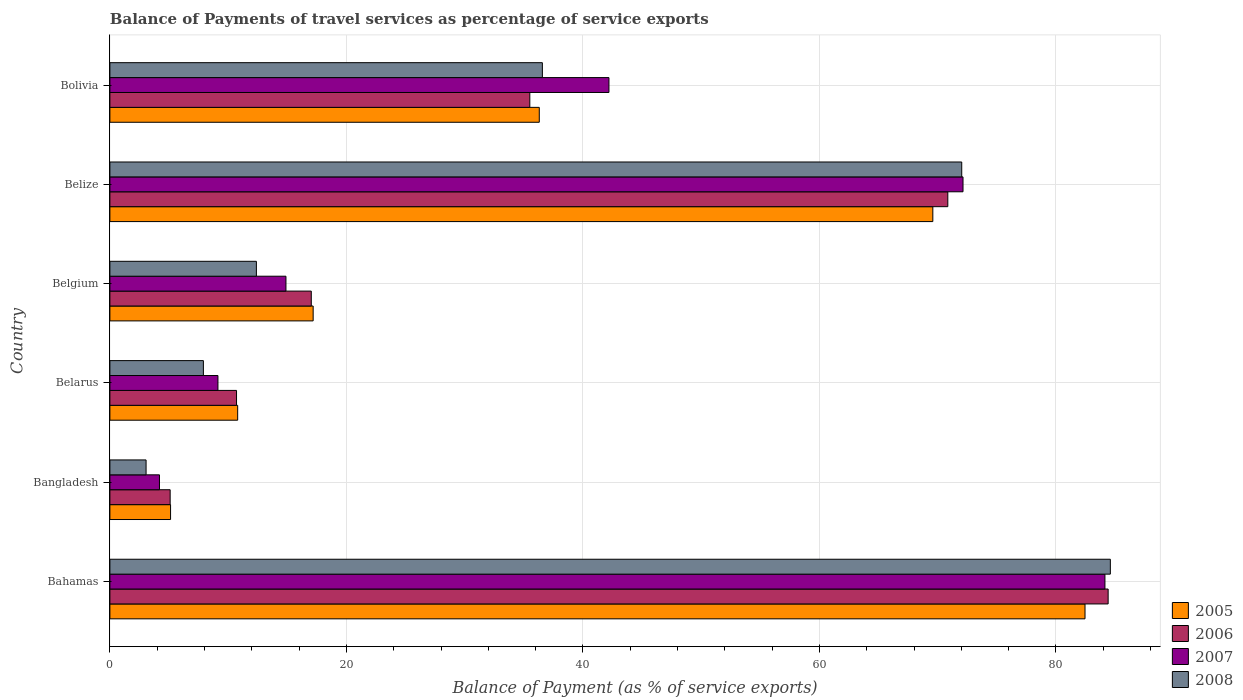How many different coloured bars are there?
Your response must be concise. 4. How many groups of bars are there?
Provide a short and direct response. 6. Are the number of bars on each tick of the Y-axis equal?
Keep it short and to the point. Yes. How many bars are there on the 4th tick from the top?
Your response must be concise. 4. What is the label of the 3rd group of bars from the top?
Keep it short and to the point. Belgium. What is the balance of payments of travel services in 2005 in Belarus?
Give a very brief answer. 10.81. Across all countries, what is the maximum balance of payments of travel services in 2006?
Your answer should be very brief. 84.42. Across all countries, what is the minimum balance of payments of travel services in 2005?
Your answer should be very brief. 5.13. In which country was the balance of payments of travel services in 2008 maximum?
Your response must be concise. Bahamas. In which country was the balance of payments of travel services in 2008 minimum?
Your response must be concise. Bangladesh. What is the total balance of payments of travel services in 2005 in the graph?
Keep it short and to the point. 221.49. What is the difference between the balance of payments of travel services in 2007 in Bangladesh and that in Bolivia?
Make the answer very short. -38.01. What is the difference between the balance of payments of travel services in 2006 in Bangladesh and the balance of payments of travel services in 2008 in Bahamas?
Provide a succinct answer. -79.51. What is the average balance of payments of travel services in 2008 per country?
Your response must be concise. 36.09. What is the difference between the balance of payments of travel services in 2007 and balance of payments of travel services in 2005 in Belarus?
Make the answer very short. -1.67. In how many countries, is the balance of payments of travel services in 2008 greater than 80 %?
Give a very brief answer. 1. What is the ratio of the balance of payments of travel services in 2005 in Bahamas to that in Belarus?
Your response must be concise. 7.63. Is the balance of payments of travel services in 2005 in Bangladesh less than that in Belgium?
Keep it short and to the point. Yes. What is the difference between the highest and the second highest balance of payments of travel services in 2006?
Offer a very short reply. 13.56. What is the difference between the highest and the lowest balance of payments of travel services in 2007?
Keep it short and to the point. 79.95. In how many countries, is the balance of payments of travel services in 2005 greater than the average balance of payments of travel services in 2005 taken over all countries?
Ensure brevity in your answer.  2. Is it the case that in every country, the sum of the balance of payments of travel services in 2005 and balance of payments of travel services in 2008 is greater than the balance of payments of travel services in 2006?
Your answer should be very brief. Yes. Are the values on the major ticks of X-axis written in scientific E-notation?
Ensure brevity in your answer.  No. Does the graph contain any zero values?
Your answer should be compact. No. Where does the legend appear in the graph?
Ensure brevity in your answer.  Bottom right. How many legend labels are there?
Offer a very short reply. 4. What is the title of the graph?
Ensure brevity in your answer.  Balance of Payments of travel services as percentage of service exports. Does "2011" appear as one of the legend labels in the graph?
Your response must be concise. No. What is the label or title of the X-axis?
Your response must be concise. Balance of Payment (as % of service exports). What is the Balance of Payment (as % of service exports) in 2005 in Bahamas?
Offer a very short reply. 82.46. What is the Balance of Payment (as % of service exports) of 2006 in Bahamas?
Offer a very short reply. 84.42. What is the Balance of Payment (as % of service exports) of 2007 in Bahamas?
Your answer should be very brief. 84.14. What is the Balance of Payment (as % of service exports) of 2008 in Bahamas?
Provide a short and direct response. 84.6. What is the Balance of Payment (as % of service exports) of 2005 in Bangladesh?
Your response must be concise. 5.13. What is the Balance of Payment (as % of service exports) of 2006 in Bangladesh?
Your response must be concise. 5.1. What is the Balance of Payment (as % of service exports) in 2007 in Bangladesh?
Provide a short and direct response. 4.19. What is the Balance of Payment (as % of service exports) of 2008 in Bangladesh?
Provide a short and direct response. 3.06. What is the Balance of Payment (as % of service exports) in 2005 in Belarus?
Keep it short and to the point. 10.81. What is the Balance of Payment (as % of service exports) in 2006 in Belarus?
Provide a short and direct response. 10.71. What is the Balance of Payment (as % of service exports) of 2007 in Belarus?
Offer a terse response. 9.14. What is the Balance of Payment (as % of service exports) in 2008 in Belarus?
Offer a terse response. 7.91. What is the Balance of Payment (as % of service exports) in 2005 in Belgium?
Provide a succinct answer. 17.19. What is the Balance of Payment (as % of service exports) in 2006 in Belgium?
Provide a short and direct response. 17.03. What is the Balance of Payment (as % of service exports) of 2007 in Belgium?
Make the answer very short. 14.89. What is the Balance of Payment (as % of service exports) of 2008 in Belgium?
Your answer should be very brief. 12.39. What is the Balance of Payment (as % of service exports) in 2005 in Belize?
Make the answer very short. 69.59. What is the Balance of Payment (as % of service exports) in 2006 in Belize?
Offer a very short reply. 70.86. What is the Balance of Payment (as % of service exports) in 2007 in Belize?
Your answer should be very brief. 72.14. What is the Balance of Payment (as % of service exports) in 2008 in Belize?
Provide a short and direct response. 72.03. What is the Balance of Payment (as % of service exports) of 2005 in Bolivia?
Provide a succinct answer. 36.31. What is the Balance of Payment (as % of service exports) of 2006 in Bolivia?
Provide a succinct answer. 35.51. What is the Balance of Payment (as % of service exports) in 2007 in Bolivia?
Your response must be concise. 42.2. What is the Balance of Payment (as % of service exports) in 2008 in Bolivia?
Make the answer very short. 36.57. Across all countries, what is the maximum Balance of Payment (as % of service exports) in 2005?
Your response must be concise. 82.46. Across all countries, what is the maximum Balance of Payment (as % of service exports) in 2006?
Make the answer very short. 84.42. Across all countries, what is the maximum Balance of Payment (as % of service exports) of 2007?
Give a very brief answer. 84.14. Across all countries, what is the maximum Balance of Payment (as % of service exports) of 2008?
Keep it short and to the point. 84.6. Across all countries, what is the minimum Balance of Payment (as % of service exports) in 2005?
Make the answer very short. 5.13. Across all countries, what is the minimum Balance of Payment (as % of service exports) of 2006?
Your response must be concise. 5.1. Across all countries, what is the minimum Balance of Payment (as % of service exports) of 2007?
Your response must be concise. 4.19. Across all countries, what is the minimum Balance of Payment (as % of service exports) in 2008?
Your answer should be very brief. 3.06. What is the total Balance of Payment (as % of service exports) of 2005 in the graph?
Keep it short and to the point. 221.49. What is the total Balance of Payment (as % of service exports) of 2006 in the graph?
Your answer should be very brief. 223.62. What is the total Balance of Payment (as % of service exports) of 2007 in the graph?
Give a very brief answer. 226.71. What is the total Balance of Payment (as % of service exports) of 2008 in the graph?
Give a very brief answer. 216.57. What is the difference between the Balance of Payment (as % of service exports) of 2005 in Bahamas and that in Bangladesh?
Provide a short and direct response. 77.33. What is the difference between the Balance of Payment (as % of service exports) in 2006 in Bahamas and that in Bangladesh?
Ensure brevity in your answer.  79.32. What is the difference between the Balance of Payment (as % of service exports) in 2007 in Bahamas and that in Bangladesh?
Keep it short and to the point. 79.95. What is the difference between the Balance of Payment (as % of service exports) in 2008 in Bahamas and that in Bangladesh?
Your answer should be very brief. 81.54. What is the difference between the Balance of Payment (as % of service exports) in 2005 in Bahamas and that in Belarus?
Offer a terse response. 71.66. What is the difference between the Balance of Payment (as % of service exports) of 2006 in Bahamas and that in Belarus?
Your response must be concise. 73.71. What is the difference between the Balance of Payment (as % of service exports) of 2007 in Bahamas and that in Belarus?
Give a very brief answer. 75.01. What is the difference between the Balance of Payment (as % of service exports) in 2008 in Bahamas and that in Belarus?
Offer a very short reply. 76.7. What is the difference between the Balance of Payment (as % of service exports) in 2005 in Bahamas and that in Belgium?
Offer a very short reply. 65.27. What is the difference between the Balance of Payment (as % of service exports) in 2006 in Bahamas and that in Belgium?
Ensure brevity in your answer.  67.38. What is the difference between the Balance of Payment (as % of service exports) of 2007 in Bahamas and that in Belgium?
Keep it short and to the point. 69.26. What is the difference between the Balance of Payment (as % of service exports) of 2008 in Bahamas and that in Belgium?
Offer a terse response. 72.21. What is the difference between the Balance of Payment (as % of service exports) in 2005 in Bahamas and that in Belize?
Offer a terse response. 12.87. What is the difference between the Balance of Payment (as % of service exports) of 2006 in Bahamas and that in Belize?
Your response must be concise. 13.56. What is the difference between the Balance of Payment (as % of service exports) in 2007 in Bahamas and that in Belize?
Make the answer very short. 12. What is the difference between the Balance of Payment (as % of service exports) in 2008 in Bahamas and that in Belize?
Ensure brevity in your answer.  12.57. What is the difference between the Balance of Payment (as % of service exports) in 2005 in Bahamas and that in Bolivia?
Offer a very short reply. 46.15. What is the difference between the Balance of Payment (as % of service exports) of 2006 in Bahamas and that in Bolivia?
Give a very brief answer. 48.91. What is the difference between the Balance of Payment (as % of service exports) in 2007 in Bahamas and that in Bolivia?
Keep it short and to the point. 41.94. What is the difference between the Balance of Payment (as % of service exports) in 2008 in Bahamas and that in Bolivia?
Make the answer very short. 48.03. What is the difference between the Balance of Payment (as % of service exports) of 2005 in Bangladesh and that in Belarus?
Give a very brief answer. -5.67. What is the difference between the Balance of Payment (as % of service exports) of 2006 in Bangladesh and that in Belarus?
Provide a short and direct response. -5.61. What is the difference between the Balance of Payment (as % of service exports) in 2007 in Bangladesh and that in Belarus?
Give a very brief answer. -4.94. What is the difference between the Balance of Payment (as % of service exports) of 2008 in Bangladesh and that in Belarus?
Your answer should be very brief. -4.85. What is the difference between the Balance of Payment (as % of service exports) in 2005 in Bangladesh and that in Belgium?
Give a very brief answer. -12.06. What is the difference between the Balance of Payment (as % of service exports) in 2006 in Bangladesh and that in Belgium?
Keep it short and to the point. -11.94. What is the difference between the Balance of Payment (as % of service exports) in 2007 in Bangladesh and that in Belgium?
Give a very brief answer. -10.69. What is the difference between the Balance of Payment (as % of service exports) of 2008 in Bangladesh and that in Belgium?
Your answer should be compact. -9.33. What is the difference between the Balance of Payment (as % of service exports) of 2005 in Bangladesh and that in Belize?
Your answer should be very brief. -64.46. What is the difference between the Balance of Payment (as % of service exports) of 2006 in Bangladesh and that in Belize?
Your response must be concise. -65.76. What is the difference between the Balance of Payment (as % of service exports) in 2007 in Bangladesh and that in Belize?
Keep it short and to the point. -67.95. What is the difference between the Balance of Payment (as % of service exports) of 2008 in Bangladesh and that in Belize?
Offer a very short reply. -68.97. What is the difference between the Balance of Payment (as % of service exports) in 2005 in Bangladesh and that in Bolivia?
Provide a succinct answer. -31.18. What is the difference between the Balance of Payment (as % of service exports) in 2006 in Bangladesh and that in Bolivia?
Give a very brief answer. -30.41. What is the difference between the Balance of Payment (as % of service exports) of 2007 in Bangladesh and that in Bolivia?
Your answer should be very brief. -38.01. What is the difference between the Balance of Payment (as % of service exports) in 2008 in Bangladesh and that in Bolivia?
Keep it short and to the point. -33.51. What is the difference between the Balance of Payment (as % of service exports) in 2005 in Belarus and that in Belgium?
Your answer should be very brief. -6.38. What is the difference between the Balance of Payment (as % of service exports) of 2006 in Belarus and that in Belgium?
Make the answer very short. -6.32. What is the difference between the Balance of Payment (as % of service exports) of 2007 in Belarus and that in Belgium?
Ensure brevity in your answer.  -5.75. What is the difference between the Balance of Payment (as % of service exports) of 2008 in Belarus and that in Belgium?
Your answer should be compact. -4.48. What is the difference between the Balance of Payment (as % of service exports) in 2005 in Belarus and that in Belize?
Your answer should be very brief. -58.78. What is the difference between the Balance of Payment (as % of service exports) in 2006 in Belarus and that in Belize?
Offer a terse response. -60.15. What is the difference between the Balance of Payment (as % of service exports) of 2007 in Belarus and that in Belize?
Provide a short and direct response. -63.01. What is the difference between the Balance of Payment (as % of service exports) in 2008 in Belarus and that in Belize?
Your response must be concise. -64.13. What is the difference between the Balance of Payment (as % of service exports) in 2005 in Belarus and that in Bolivia?
Keep it short and to the point. -25.5. What is the difference between the Balance of Payment (as % of service exports) of 2006 in Belarus and that in Bolivia?
Offer a very short reply. -24.8. What is the difference between the Balance of Payment (as % of service exports) of 2007 in Belarus and that in Bolivia?
Your response must be concise. -33.07. What is the difference between the Balance of Payment (as % of service exports) in 2008 in Belarus and that in Bolivia?
Give a very brief answer. -28.67. What is the difference between the Balance of Payment (as % of service exports) in 2005 in Belgium and that in Belize?
Make the answer very short. -52.4. What is the difference between the Balance of Payment (as % of service exports) in 2006 in Belgium and that in Belize?
Offer a terse response. -53.83. What is the difference between the Balance of Payment (as % of service exports) in 2007 in Belgium and that in Belize?
Provide a short and direct response. -57.26. What is the difference between the Balance of Payment (as % of service exports) of 2008 in Belgium and that in Belize?
Your answer should be compact. -59.65. What is the difference between the Balance of Payment (as % of service exports) in 2005 in Belgium and that in Bolivia?
Your answer should be compact. -19.12. What is the difference between the Balance of Payment (as % of service exports) of 2006 in Belgium and that in Bolivia?
Your answer should be compact. -18.48. What is the difference between the Balance of Payment (as % of service exports) in 2007 in Belgium and that in Bolivia?
Keep it short and to the point. -27.31. What is the difference between the Balance of Payment (as % of service exports) in 2008 in Belgium and that in Bolivia?
Provide a succinct answer. -24.18. What is the difference between the Balance of Payment (as % of service exports) of 2005 in Belize and that in Bolivia?
Make the answer very short. 33.28. What is the difference between the Balance of Payment (as % of service exports) of 2006 in Belize and that in Bolivia?
Give a very brief answer. 35.35. What is the difference between the Balance of Payment (as % of service exports) of 2007 in Belize and that in Bolivia?
Offer a very short reply. 29.94. What is the difference between the Balance of Payment (as % of service exports) in 2008 in Belize and that in Bolivia?
Keep it short and to the point. 35.46. What is the difference between the Balance of Payment (as % of service exports) of 2005 in Bahamas and the Balance of Payment (as % of service exports) of 2006 in Bangladesh?
Give a very brief answer. 77.36. What is the difference between the Balance of Payment (as % of service exports) of 2005 in Bahamas and the Balance of Payment (as % of service exports) of 2007 in Bangladesh?
Your answer should be very brief. 78.27. What is the difference between the Balance of Payment (as % of service exports) of 2005 in Bahamas and the Balance of Payment (as % of service exports) of 2008 in Bangladesh?
Keep it short and to the point. 79.4. What is the difference between the Balance of Payment (as % of service exports) in 2006 in Bahamas and the Balance of Payment (as % of service exports) in 2007 in Bangladesh?
Provide a succinct answer. 80.22. What is the difference between the Balance of Payment (as % of service exports) of 2006 in Bahamas and the Balance of Payment (as % of service exports) of 2008 in Bangladesh?
Offer a very short reply. 81.36. What is the difference between the Balance of Payment (as % of service exports) in 2007 in Bahamas and the Balance of Payment (as % of service exports) in 2008 in Bangladesh?
Make the answer very short. 81.08. What is the difference between the Balance of Payment (as % of service exports) of 2005 in Bahamas and the Balance of Payment (as % of service exports) of 2006 in Belarus?
Your answer should be very brief. 71.75. What is the difference between the Balance of Payment (as % of service exports) in 2005 in Bahamas and the Balance of Payment (as % of service exports) in 2007 in Belarus?
Give a very brief answer. 73.32. What is the difference between the Balance of Payment (as % of service exports) in 2005 in Bahamas and the Balance of Payment (as % of service exports) in 2008 in Belarus?
Your answer should be very brief. 74.55. What is the difference between the Balance of Payment (as % of service exports) in 2006 in Bahamas and the Balance of Payment (as % of service exports) in 2007 in Belarus?
Your response must be concise. 75.28. What is the difference between the Balance of Payment (as % of service exports) in 2006 in Bahamas and the Balance of Payment (as % of service exports) in 2008 in Belarus?
Offer a terse response. 76.51. What is the difference between the Balance of Payment (as % of service exports) of 2007 in Bahamas and the Balance of Payment (as % of service exports) of 2008 in Belarus?
Your response must be concise. 76.24. What is the difference between the Balance of Payment (as % of service exports) of 2005 in Bahamas and the Balance of Payment (as % of service exports) of 2006 in Belgium?
Make the answer very short. 65.43. What is the difference between the Balance of Payment (as % of service exports) in 2005 in Bahamas and the Balance of Payment (as % of service exports) in 2007 in Belgium?
Give a very brief answer. 67.57. What is the difference between the Balance of Payment (as % of service exports) of 2005 in Bahamas and the Balance of Payment (as % of service exports) of 2008 in Belgium?
Your answer should be very brief. 70.07. What is the difference between the Balance of Payment (as % of service exports) of 2006 in Bahamas and the Balance of Payment (as % of service exports) of 2007 in Belgium?
Provide a short and direct response. 69.53. What is the difference between the Balance of Payment (as % of service exports) of 2006 in Bahamas and the Balance of Payment (as % of service exports) of 2008 in Belgium?
Make the answer very short. 72.03. What is the difference between the Balance of Payment (as % of service exports) in 2007 in Bahamas and the Balance of Payment (as % of service exports) in 2008 in Belgium?
Keep it short and to the point. 71.76. What is the difference between the Balance of Payment (as % of service exports) in 2005 in Bahamas and the Balance of Payment (as % of service exports) in 2006 in Belize?
Keep it short and to the point. 11.6. What is the difference between the Balance of Payment (as % of service exports) of 2005 in Bahamas and the Balance of Payment (as % of service exports) of 2007 in Belize?
Make the answer very short. 10.32. What is the difference between the Balance of Payment (as % of service exports) in 2005 in Bahamas and the Balance of Payment (as % of service exports) in 2008 in Belize?
Offer a very short reply. 10.43. What is the difference between the Balance of Payment (as % of service exports) of 2006 in Bahamas and the Balance of Payment (as % of service exports) of 2007 in Belize?
Offer a terse response. 12.27. What is the difference between the Balance of Payment (as % of service exports) of 2006 in Bahamas and the Balance of Payment (as % of service exports) of 2008 in Belize?
Give a very brief answer. 12.38. What is the difference between the Balance of Payment (as % of service exports) in 2007 in Bahamas and the Balance of Payment (as % of service exports) in 2008 in Belize?
Offer a terse response. 12.11. What is the difference between the Balance of Payment (as % of service exports) in 2005 in Bahamas and the Balance of Payment (as % of service exports) in 2006 in Bolivia?
Ensure brevity in your answer.  46.95. What is the difference between the Balance of Payment (as % of service exports) in 2005 in Bahamas and the Balance of Payment (as % of service exports) in 2007 in Bolivia?
Ensure brevity in your answer.  40.26. What is the difference between the Balance of Payment (as % of service exports) of 2005 in Bahamas and the Balance of Payment (as % of service exports) of 2008 in Bolivia?
Offer a very short reply. 45.89. What is the difference between the Balance of Payment (as % of service exports) in 2006 in Bahamas and the Balance of Payment (as % of service exports) in 2007 in Bolivia?
Offer a terse response. 42.21. What is the difference between the Balance of Payment (as % of service exports) of 2006 in Bahamas and the Balance of Payment (as % of service exports) of 2008 in Bolivia?
Provide a succinct answer. 47.84. What is the difference between the Balance of Payment (as % of service exports) of 2007 in Bahamas and the Balance of Payment (as % of service exports) of 2008 in Bolivia?
Ensure brevity in your answer.  47.57. What is the difference between the Balance of Payment (as % of service exports) of 2005 in Bangladesh and the Balance of Payment (as % of service exports) of 2006 in Belarus?
Keep it short and to the point. -5.58. What is the difference between the Balance of Payment (as % of service exports) in 2005 in Bangladesh and the Balance of Payment (as % of service exports) in 2007 in Belarus?
Provide a succinct answer. -4.01. What is the difference between the Balance of Payment (as % of service exports) of 2005 in Bangladesh and the Balance of Payment (as % of service exports) of 2008 in Belarus?
Your answer should be compact. -2.78. What is the difference between the Balance of Payment (as % of service exports) of 2006 in Bangladesh and the Balance of Payment (as % of service exports) of 2007 in Belarus?
Make the answer very short. -4.04. What is the difference between the Balance of Payment (as % of service exports) in 2006 in Bangladesh and the Balance of Payment (as % of service exports) in 2008 in Belarus?
Give a very brief answer. -2.81. What is the difference between the Balance of Payment (as % of service exports) of 2007 in Bangladesh and the Balance of Payment (as % of service exports) of 2008 in Belarus?
Your answer should be very brief. -3.71. What is the difference between the Balance of Payment (as % of service exports) of 2005 in Bangladesh and the Balance of Payment (as % of service exports) of 2006 in Belgium?
Your response must be concise. -11.9. What is the difference between the Balance of Payment (as % of service exports) of 2005 in Bangladesh and the Balance of Payment (as % of service exports) of 2007 in Belgium?
Provide a short and direct response. -9.76. What is the difference between the Balance of Payment (as % of service exports) of 2005 in Bangladesh and the Balance of Payment (as % of service exports) of 2008 in Belgium?
Your answer should be compact. -7.26. What is the difference between the Balance of Payment (as % of service exports) of 2006 in Bangladesh and the Balance of Payment (as % of service exports) of 2007 in Belgium?
Provide a short and direct response. -9.79. What is the difference between the Balance of Payment (as % of service exports) of 2006 in Bangladesh and the Balance of Payment (as % of service exports) of 2008 in Belgium?
Offer a very short reply. -7.29. What is the difference between the Balance of Payment (as % of service exports) in 2007 in Bangladesh and the Balance of Payment (as % of service exports) in 2008 in Belgium?
Give a very brief answer. -8.2. What is the difference between the Balance of Payment (as % of service exports) of 2005 in Bangladesh and the Balance of Payment (as % of service exports) of 2006 in Belize?
Give a very brief answer. -65.73. What is the difference between the Balance of Payment (as % of service exports) of 2005 in Bangladesh and the Balance of Payment (as % of service exports) of 2007 in Belize?
Your answer should be compact. -67.01. What is the difference between the Balance of Payment (as % of service exports) in 2005 in Bangladesh and the Balance of Payment (as % of service exports) in 2008 in Belize?
Your answer should be compact. -66.9. What is the difference between the Balance of Payment (as % of service exports) in 2006 in Bangladesh and the Balance of Payment (as % of service exports) in 2007 in Belize?
Make the answer very short. -67.05. What is the difference between the Balance of Payment (as % of service exports) in 2006 in Bangladesh and the Balance of Payment (as % of service exports) in 2008 in Belize?
Your response must be concise. -66.94. What is the difference between the Balance of Payment (as % of service exports) of 2007 in Bangladesh and the Balance of Payment (as % of service exports) of 2008 in Belize?
Offer a terse response. -67.84. What is the difference between the Balance of Payment (as % of service exports) in 2005 in Bangladesh and the Balance of Payment (as % of service exports) in 2006 in Bolivia?
Ensure brevity in your answer.  -30.38. What is the difference between the Balance of Payment (as % of service exports) of 2005 in Bangladesh and the Balance of Payment (as % of service exports) of 2007 in Bolivia?
Offer a terse response. -37.07. What is the difference between the Balance of Payment (as % of service exports) in 2005 in Bangladesh and the Balance of Payment (as % of service exports) in 2008 in Bolivia?
Give a very brief answer. -31.44. What is the difference between the Balance of Payment (as % of service exports) in 2006 in Bangladesh and the Balance of Payment (as % of service exports) in 2007 in Bolivia?
Offer a very short reply. -37.11. What is the difference between the Balance of Payment (as % of service exports) of 2006 in Bangladesh and the Balance of Payment (as % of service exports) of 2008 in Bolivia?
Offer a very short reply. -31.48. What is the difference between the Balance of Payment (as % of service exports) in 2007 in Bangladesh and the Balance of Payment (as % of service exports) in 2008 in Bolivia?
Give a very brief answer. -32.38. What is the difference between the Balance of Payment (as % of service exports) in 2005 in Belarus and the Balance of Payment (as % of service exports) in 2006 in Belgium?
Your answer should be compact. -6.23. What is the difference between the Balance of Payment (as % of service exports) in 2005 in Belarus and the Balance of Payment (as % of service exports) in 2007 in Belgium?
Ensure brevity in your answer.  -4.08. What is the difference between the Balance of Payment (as % of service exports) in 2005 in Belarus and the Balance of Payment (as % of service exports) in 2008 in Belgium?
Your answer should be compact. -1.58. What is the difference between the Balance of Payment (as % of service exports) in 2006 in Belarus and the Balance of Payment (as % of service exports) in 2007 in Belgium?
Ensure brevity in your answer.  -4.18. What is the difference between the Balance of Payment (as % of service exports) of 2006 in Belarus and the Balance of Payment (as % of service exports) of 2008 in Belgium?
Keep it short and to the point. -1.68. What is the difference between the Balance of Payment (as % of service exports) of 2007 in Belarus and the Balance of Payment (as % of service exports) of 2008 in Belgium?
Ensure brevity in your answer.  -3.25. What is the difference between the Balance of Payment (as % of service exports) in 2005 in Belarus and the Balance of Payment (as % of service exports) in 2006 in Belize?
Your answer should be very brief. -60.05. What is the difference between the Balance of Payment (as % of service exports) of 2005 in Belarus and the Balance of Payment (as % of service exports) of 2007 in Belize?
Your answer should be compact. -61.34. What is the difference between the Balance of Payment (as % of service exports) of 2005 in Belarus and the Balance of Payment (as % of service exports) of 2008 in Belize?
Offer a terse response. -61.23. What is the difference between the Balance of Payment (as % of service exports) of 2006 in Belarus and the Balance of Payment (as % of service exports) of 2007 in Belize?
Keep it short and to the point. -61.43. What is the difference between the Balance of Payment (as % of service exports) of 2006 in Belarus and the Balance of Payment (as % of service exports) of 2008 in Belize?
Your response must be concise. -61.33. What is the difference between the Balance of Payment (as % of service exports) in 2007 in Belarus and the Balance of Payment (as % of service exports) in 2008 in Belize?
Your answer should be compact. -62.9. What is the difference between the Balance of Payment (as % of service exports) of 2005 in Belarus and the Balance of Payment (as % of service exports) of 2006 in Bolivia?
Provide a succinct answer. -24.7. What is the difference between the Balance of Payment (as % of service exports) of 2005 in Belarus and the Balance of Payment (as % of service exports) of 2007 in Bolivia?
Your answer should be very brief. -31.4. What is the difference between the Balance of Payment (as % of service exports) of 2005 in Belarus and the Balance of Payment (as % of service exports) of 2008 in Bolivia?
Your answer should be very brief. -25.77. What is the difference between the Balance of Payment (as % of service exports) of 2006 in Belarus and the Balance of Payment (as % of service exports) of 2007 in Bolivia?
Ensure brevity in your answer.  -31.49. What is the difference between the Balance of Payment (as % of service exports) in 2006 in Belarus and the Balance of Payment (as % of service exports) in 2008 in Bolivia?
Offer a terse response. -25.86. What is the difference between the Balance of Payment (as % of service exports) of 2007 in Belarus and the Balance of Payment (as % of service exports) of 2008 in Bolivia?
Make the answer very short. -27.44. What is the difference between the Balance of Payment (as % of service exports) in 2005 in Belgium and the Balance of Payment (as % of service exports) in 2006 in Belize?
Provide a short and direct response. -53.67. What is the difference between the Balance of Payment (as % of service exports) of 2005 in Belgium and the Balance of Payment (as % of service exports) of 2007 in Belize?
Offer a very short reply. -54.95. What is the difference between the Balance of Payment (as % of service exports) in 2005 in Belgium and the Balance of Payment (as % of service exports) in 2008 in Belize?
Your response must be concise. -54.85. What is the difference between the Balance of Payment (as % of service exports) in 2006 in Belgium and the Balance of Payment (as % of service exports) in 2007 in Belize?
Keep it short and to the point. -55.11. What is the difference between the Balance of Payment (as % of service exports) in 2006 in Belgium and the Balance of Payment (as % of service exports) in 2008 in Belize?
Your response must be concise. -55. What is the difference between the Balance of Payment (as % of service exports) of 2007 in Belgium and the Balance of Payment (as % of service exports) of 2008 in Belize?
Your answer should be compact. -57.15. What is the difference between the Balance of Payment (as % of service exports) in 2005 in Belgium and the Balance of Payment (as % of service exports) in 2006 in Bolivia?
Offer a very short reply. -18.32. What is the difference between the Balance of Payment (as % of service exports) of 2005 in Belgium and the Balance of Payment (as % of service exports) of 2007 in Bolivia?
Your answer should be very brief. -25.01. What is the difference between the Balance of Payment (as % of service exports) in 2005 in Belgium and the Balance of Payment (as % of service exports) in 2008 in Bolivia?
Your answer should be very brief. -19.38. What is the difference between the Balance of Payment (as % of service exports) of 2006 in Belgium and the Balance of Payment (as % of service exports) of 2007 in Bolivia?
Give a very brief answer. -25.17. What is the difference between the Balance of Payment (as % of service exports) in 2006 in Belgium and the Balance of Payment (as % of service exports) in 2008 in Bolivia?
Your answer should be compact. -19.54. What is the difference between the Balance of Payment (as % of service exports) in 2007 in Belgium and the Balance of Payment (as % of service exports) in 2008 in Bolivia?
Keep it short and to the point. -21.68. What is the difference between the Balance of Payment (as % of service exports) of 2005 in Belize and the Balance of Payment (as % of service exports) of 2006 in Bolivia?
Make the answer very short. 34.08. What is the difference between the Balance of Payment (as % of service exports) in 2005 in Belize and the Balance of Payment (as % of service exports) in 2007 in Bolivia?
Offer a terse response. 27.39. What is the difference between the Balance of Payment (as % of service exports) in 2005 in Belize and the Balance of Payment (as % of service exports) in 2008 in Bolivia?
Keep it short and to the point. 33.02. What is the difference between the Balance of Payment (as % of service exports) in 2006 in Belize and the Balance of Payment (as % of service exports) in 2007 in Bolivia?
Make the answer very short. 28.66. What is the difference between the Balance of Payment (as % of service exports) of 2006 in Belize and the Balance of Payment (as % of service exports) of 2008 in Bolivia?
Provide a succinct answer. 34.29. What is the difference between the Balance of Payment (as % of service exports) of 2007 in Belize and the Balance of Payment (as % of service exports) of 2008 in Bolivia?
Provide a succinct answer. 35.57. What is the average Balance of Payment (as % of service exports) in 2005 per country?
Ensure brevity in your answer.  36.91. What is the average Balance of Payment (as % of service exports) of 2006 per country?
Your answer should be compact. 37.27. What is the average Balance of Payment (as % of service exports) in 2007 per country?
Offer a terse response. 37.78. What is the average Balance of Payment (as % of service exports) in 2008 per country?
Offer a terse response. 36.09. What is the difference between the Balance of Payment (as % of service exports) of 2005 and Balance of Payment (as % of service exports) of 2006 in Bahamas?
Your answer should be compact. -1.95. What is the difference between the Balance of Payment (as % of service exports) in 2005 and Balance of Payment (as % of service exports) in 2007 in Bahamas?
Give a very brief answer. -1.68. What is the difference between the Balance of Payment (as % of service exports) of 2005 and Balance of Payment (as % of service exports) of 2008 in Bahamas?
Your answer should be very brief. -2.14. What is the difference between the Balance of Payment (as % of service exports) in 2006 and Balance of Payment (as % of service exports) in 2007 in Bahamas?
Keep it short and to the point. 0.27. What is the difference between the Balance of Payment (as % of service exports) in 2006 and Balance of Payment (as % of service exports) in 2008 in Bahamas?
Provide a short and direct response. -0.19. What is the difference between the Balance of Payment (as % of service exports) in 2007 and Balance of Payment (as % of service exports) in 2008 in Bahamas?
Ensure brevity in your answer.  -0.46. What is the difference between the Balance of Payment (as % of service exports) in 2005 and Balance of Payment (as % of service exports) in 2006 in Bangladesh?
Make the answer very short. 0.04. What is the difference between the Balance of Payment (as % of service exports) of 2005 and Balance of Payment (as % of service exports) of 2007 in Bangladesh?
Ensure brevity in your answer.  0.94. What is the difference between the Balance of Payment (as % of service exports) in 2005 and Balance of Payment (as % of service exports) in 2008 in Bangladesh?
Your answer should be very brief. 2.07. What is the difference between the Balance of Payment (as % of service exports) of 2006 and Balance of Payment (as % of service exports) of 2007 in Bangladesh?
Keep it short and to the point. 0.9. What is the difference between the Balance of Payment (as % of service exports) of 2006 and Balance of Payment (as % of service exports) of 2008 in Bangladesh?
Make the answer very short. 2.04. What is the difference between the Balance of Payment (as % of service exports) in 2007 and Balance of Payment (as % of service exports) in 2008 in Bangladesh?
Keep it short and to the point. 1.13. What is the difference between the Balance of Payment (as % of service exports) in 2005 and Balance of Payment (as % of service exports) in 2006 in Belarus?
Offer a very short reply. 0.1. What is the difference between the Balance of Payment (as % of service exports) in 2005 and Balance of Payment (as % of service exports) in 2007 in Belarus?
Offer a terse response. 1.67. What is the difference between the Balance of Payment (as % of service exports) of 2005 and Balance of Payment (as % of service exports) of 2008 in Belarus?
Your answer should be compact. 2.9. What is the difference between the Balance of Payment (as % of service exports) of 2006 and Balance of Payment (as % of service exports) of 2007 in Belarus?
Offer a very short reply. 1.57. What is the difference between the Balance of Payment (as % of service exports) of 2006 and Balance of Payment (as % of service exports) of 2008 in Belarus?
Your answer should be compact. 2.8. What is the difference between the Balance of Payment (as % of service exports) in 2007 and Balance of Payment (as % of service exports) in 2008 in Belarus?
Your answer should be very brief. 1.23. What is the difference between the Balance of Payment (as % of service exports) of 2005 and Balance of Payment (as % of service exports) of 2006 in Belgium?
Ensure brevity in your answer.  0.16. What is the difference between the Balance of Payment (as % of service exports) of 2005 and Balance of Payment (as % of service exports) of 2007 in Belgium?
Your answer should be very brief. 2.3. What is the difference between the Balance of Payment (as % of service exports) of 2005 and Balance of Payment (as % of service exports) of 2008 in Belgium?
Ensure brevity in your answer.  4.8. What is the difference between the Balance of Payment (as % of service exports) in 2006 and Balance of Payment (as % of service exports) in 2007 in Belgium?
Keep it short and to the point. 2.14. What is the difference between the Balance of Payment (as % of service exports) in 2006 and Balance of Payment (as % of service exports) in 2008 in Belgium?
Your answer should be compact. 4.64. What is the difference between the Balance of Payment (as % of service exports) of 2007 and Balance of Payment (as % of service exports) of 2008 in Belgium?
Provide a succinct answer. 2.5. What is the difference between the Balance of Payment (as % of service exports) in 2005 and Balance of Payment (as % of service exports) in 2006 in Belize?
Your response must be concise. -1.27. What is the difference between the Balance of Payment (as % of service exports) of 2005 and Balance of Payment (as % of service exports) of 2007 in Belize?
Provide a short and direct response. -2.55. What is the difference between the Balance of Payment (as % of service exports) of 2005 and Balance of Payment (as % of service exports) of 2008 in Belize?
Your answer should be very brief. -2.44. What is the difference between the Balance of Payment (as % of service exports) of 2006 and Balance of Payment (as % of service exports) of 2007 in Belize?
Your answer should be very brief. -1.28. What is the difference between the Balance of Payment (as % of service exports) of 2006 and Balance of Payment (as % of service exports) of 2008 in Belize?
Offer a terse response. -1.18. What is the difference between the Balance of Payment (as % of service exports) of 2007 and Balance of Payment (as % of service exports) of 2008 in Belize?
Make the answer very short. 0.11. What is the difference between the Balance of Payment (as % of service exports) in 2005 and Balance of Payment (as % of service exports) in 2006 in Bolivia?
Your response must be concise. 0.8. What is the difference between the Balance of Payment (as % of service exports) in 2005 and Balance of Payment (as % of service exports) in 2007 in Bolivia?
Your answer should be very brief. -5.89. What is the difference between the Balance of Payment (as % of service exports) of 2005 and Balance of Payment (as % of service exports) of 2008 in Bolivia?
Provide a succinct answer. -0.26. What is the difference between the Balance of Payment (as % of service exports) in 2006 and Balance of Payment (as % of service exports) in 2007 in Bolivia?
Keep it short and to the point. -6.69. What is the difference between the Balance of Payment (as % of service exports) in 2006 and Balance of Payment (as % of service exports) in 2008 in Bolivia?
Your response must be concise. -1.06. What is the difference between the Balance of Payment (as % of service exports) of 2007 and Balance of Payment (as % of service exports) of 2008 in Bolivia?
Your answer should be compact. 5.63. What is the ratio of the Balance of Payment (as % of service exports) of 2005 in Bahamas to that in Bangladesh?
Offer a terse response. 16.07. What is the ratio of the Balance of Payment (as % of service exports) of 2006 in Bahamas to that in Bangladesh?
Keep it short and to the point. 16.57. What is the ratio of the Balance of Payment (as % of service exports) in 2007 in Bahamas to that in Bangladesh?
Ensure brevity in your answer.  20.07. What is the ratio of the Balance of Payment (as % of service exports) of 2008 in Bahamas to that in Bangladesh?
Provide a succinct answer. 27.64. What is the ratio of the Balance of Payment (as % of service exports) in 2005 in Bahamas to that in Belarus?
Ensure brevity in your answer.  7.63. What is the ratio of the Balance of Payment (as % of service exports) in 2006 in Bahamas to that in Belarus?
Your answer should be compact. 7.88. What is the ratio of the Balance of Payment (as % of service exports) of 2007 in Bahamas to that in Belarus?
Your answer should be compact. 9.21. What is the ratio of the Balance of Payment (as % of service exports) of 2008 in Bahamas to that in Belarus?
Ensure brevity in your answer.  10.7. What is the ratio of the Balance of Payment (as % of service exports) of 2005 in Bahamas to that in Belgium?
Your answer should be compact. 4.8. What is the ratio of the Balance of Payment (as % of service exports) of 2006 in Bahamas to that in Belgium?
Keep it short and to the point. 4.96. What is the ratio of the Balance of Payment (as % of service exports) in 2007 in Bahamas to that in Belgium?
Your answer should be compact. 5.65. What is the ratio of the Balance of Payment (as % of service exports) of 2008 in Bahamas to that in Belgium?
Ensure brevity in your answer.  6.83. What is the ratio of the Balance of Payment (as % of service exports) of 2005 in Bahamas to that in Belize?
Offer a very short reply. 1.18. What is the ratio of the Balance of Payment (as % of service exports) in 2006 in Bahamas to that in Belize?
Provide a succinct answer. 1.19. What is the ratio of the Balance of Payment (as % of service exports) in 2007 in Bahamas to that in Belize?
Provide a succinct answer. 1.17. What is the ratio of the Balance of Payment (as % of service exports) in 2008 in Bahamas to that in Belize?
Your response must be concise. 1.17. What is the ratio of the Balance of Payment (as % of service exports) of 2005 in Bahamas to that in Bolivia?
Your answer should be compact. 2.27. What is the ratio of the Balance of Payment (as % of service exports) in 2006 in Bahamas to that in Bolivia?
Ensure brevity in your answer.  2.38. What is the ratio of the Balance of Payment (as % of service exports) of 2007 in Bahamas to that in Bolivia?
Make the answer very short. 1.99. What is the ratio of the Balance of Payment (as % of service exports) in 2008 in Bahamas to that in Bolivia?
Offer a terse response. 2.31. What is the ratio of the Balance of Payment (as % of service exports) in 2005 in Bangladesh to that in Belarus?
Your response must be concise. 0.47. What is the ratio of the Balance of Payment (as % of service exports) in 2006 in Bangladesh to that in Belarus?
Provide a succinct answer. 0.48. What is the ratio of the Balance of Payment (as % of service exports) in 2007 in Bangladesh to that in Belarus?
Give a very brief answer. 0.46. What is the ratio of the Balance of Payment (as % of service exports) of 2008 in Bangladesh to that in Belarus?
Offer a very short reply. 0.39. What is the ratio of the Balance of Payment (as % of service exports) in 2005 in Bangladesh to that in Belgium?
Ensure brevity in your answer.  0.3. What is the ratio of the Balance of Payment (as % of service exports) in 2006 in Bangladesh to that in Belgium?
Your response must be concise. 0.3. What is the ratio of the Balance of Payment (as % of service exports) in 2007 in Bangladesh to that in Belgium?
Ensure brevity in your answer.  0.28. What is the ratio of the Balance of Payment (as % of service exports) of 2008 in Bangladesh to that in Belgium?
Provide a short and direct response. 0.25. What is the ratio of the Balance of Payment (as % of service exports) in 2005 in Bangladesh to that in Belize?
Offer a very short reply. 0.07. What is the ratio of the Balance of Payment (as % of service exports) in 2006 in Bangladesh to that in Belize?
Ensure brevity in your answer.  0.07. What is the ratio of the Balance of Payment (as % of service exports) of 2007 in Bangladesh to that in Belize?
Provide a short and direct response. 0.06. What is the ratio of the Balance of Payment (as % of service exports) of 2008 in Bangladesh to that in Belize?
Offer a terse response. 0.04. What is the ratio of the Balance of Payment (as % of service exports) in 2005 in Bangladesh to that in Bolivia?
Ensure brevity in your answer.  0.14. What is the ratio of the Balance of Payment (as % of service exports) of 2006 in Bangladesh to that in Bolivia?
Make the answer very short. 0.14. What is the ratio of the Balance of Payment (as % of service exports) in 2007 in Bangladesh to that in Bolivia?
Keep it short and to the point. 0.1. What is the ratio of the Balance of Payment (as % of service exports) in 2008 in Bangladesh to that in Bolivia?
Provide a short and direct response. 0.08. What is the ratio of the Balance of Payment (as % of service exports) of 2005 in Belarus to that in Belgium?
Your answer should be very brief. 0.63. What is the ratio of the Balance of Payment (as % of service exports) in 2006 in Belarus to that in Belgium?
Keep it short and to the point. 0.63. What is the ratio of the Balance of Payment (as % of service exports) in 2007 in Belarus to that in Belgium?
Offer a very short reply. 0.61. What is the ratio of the Balance of Payment (as % of service exports) in 2008 in Belarus to that in Belgium?
Give a very brief answer. 0.64. What is the ratio of the Balance of Payment (as % of service exports) in 2005 in Belarus to that in Belize?
Make the answer very short. 0.16. What is the ratio of the Balance of Payment (as % of service exports) of 2006 in Belarus to that in Belize?
Offer a very short reply. 0.15. What is the ratio of the Balance of Payment (as % of service exports) of 2007 in Belarus to that in Belize?
Your answer should be very brief. 0.13. What is the ratio of the Balance of Payment (as % of service exports) in 2008 in Belarus to that in Belize?
Your answer should be compact. 0.11. What is the ratio of the Balance of Payment (as % of service exports) of 2005 in Belarus to that in Bolivia?
Provide a succinct answer. 0.3. What is the ratio of the Balance of Payment (as % of service exports) of 2006 in Belarus to that in Bolivia?
Offer a very short reply. 0.3. What is the ratio of the Balance of Payment (as % of service exports) of 2007 in Belarus to that in Bolivia?
Your response must be concise. 0.22. What is the ratio of the Balance of Payment (as % of service exports) of 2008 in Belarus to that in Bolivia?
Offer a terse response. 0.22. What is the ratio of the Balance of Payment (as % of service exports) in 2005 in Belgium to that in Belize?
Your answer should be very brief. 0.25. What is the ratio of the Balance of Payment (as % of service exports) of 2006 in Belgium to that in Belize?
Your answer should be very brief. 0.24. What is the ratio of the Balance of Payment (as % of service exports) of 2007 in Belgium to that in Belize?
Make the answer very short. 0.21. What is the ratio of the Balance of Payment (as % of service exports) of 2008 in Belgium to that in Belize?
Your answer should be very brief. 0.17. What is the ratio of the Balance of Payment (as % of service exports) of 2005 in Belgium to that in Bolivia?
Ensure brevity in your answer.  0.47. What is the ratio of the Balance of Payment (as % of service exports) in 2006 in Belgium to that in Bolivia?
Your answer should be compact. 0.48. What is the ratio of the Balance of Payment (as % of service exports) of 2007 in Belgium to that in Bolivia?
Offer a terse response. 0.35. What is the ratio of the Balance of Payment (as % of service exports) in 2008 in Belgium to that in Bolivia?
Offer a terse response. 0.34. What is the ratio of the Balance of Payment (as % of service exports) of 2005 in Belize to that in Bolivia?
Provide a short and direct response. 1.92. What is the ratio of the Balance of Payment (as % of service exports) of 2006 in Belize to that in Bolivia?
Offer a terse response. 2. What is the ratio of the Balance of Payment (as % of service exports) of 2007 in Belize to that in Bolivia?
Keep it short and to the point. 1.71. What is the ratio of the Balance of Payment (as % of service exports) in 2008 in Belize to that in Bolivia?
Offer a terse response. 1.97. What is the difference between the highest and the second highest Balance of Payment (as % of service exports) of 2005?
Your response must be concise. 12.87. What is the difference between the highest and the second highest Balance of Payment (as % of service exports) of 2006?
Offer a terse response. 13.56. What is the difference between the highest and the second highest Balance of Payment (as % of service exports) in 2007?
Make the answer very short. 12. What is the difference between the highest and the second highest Balance of Payment (as % of service exports) in 2008?
Keep it short and to the point. 12.57. What is the difference between the highest and the lowest Balance of Payment (as % of service exports) of 2005?
Offer a terse response. 77.33. What is the difference between the highest and the lowest Balance of Payment (as % of service exports) of 2006?
Provide a succinct answer. 79.32. What is the difference between the highest and the lowest Balance of Payment (as % of service exports) of 2007?
Provide a short and direct response. 79.95. What is the difference between the highest and the lowest Balance of Payment (as % of service exports) of 2008?
Your answer should be compact. 81.54. 